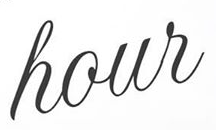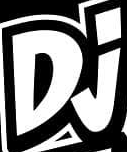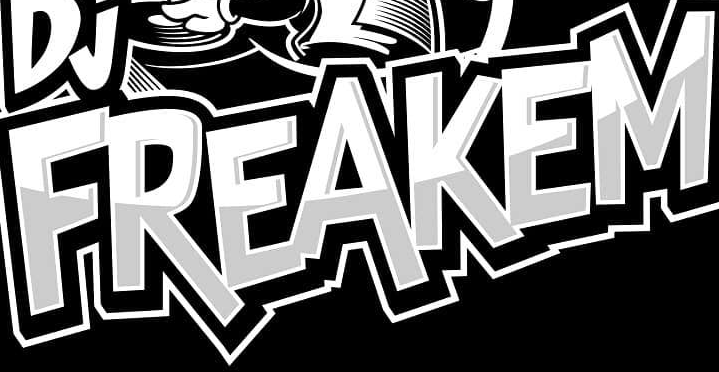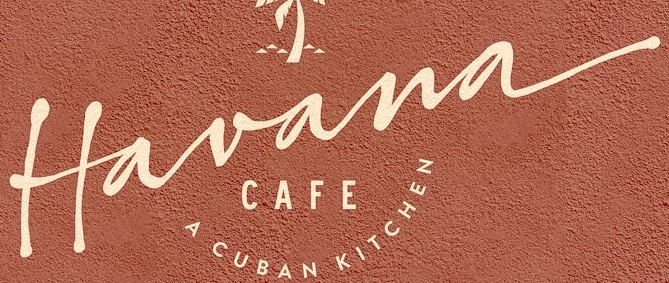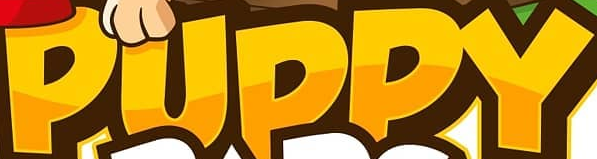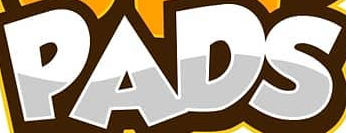Transcribe the words shown in these images in order, separated by a semicolon. hour; Dj; FREAKEM; Havana; PUPPY; PADS 